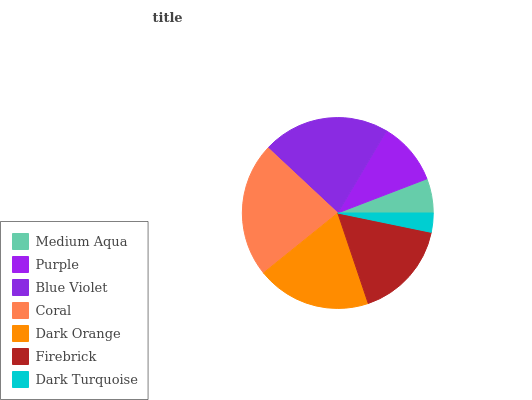Is Dark Turquoise the minimum?
Answer yes or no. Yes. Is Coral the maximum?
Answer yes or no. Yes. Is Purple the minimum?
Answer yes or no. No. Is Purple the maximum?
Answer yes or no. No. Is Purple greater than Medium Aqua?
Answer yes or no. Yes. Is Medium Aqua less than Purple?
Answer yes or no. Yes. Is Medium Aqua greater than Purple?
Answer yes or no. No. Is Purple less than Medium Aqua?
Answer yes or no. No. Is Firebrick the high median?
Answer yes or no. Yes. Is Firebrick the low median?
Answer yes or no. Yes. Is Coral the high median?
Answer yes or no. No. Is Purple the low median?
Answer yes or no. No. 